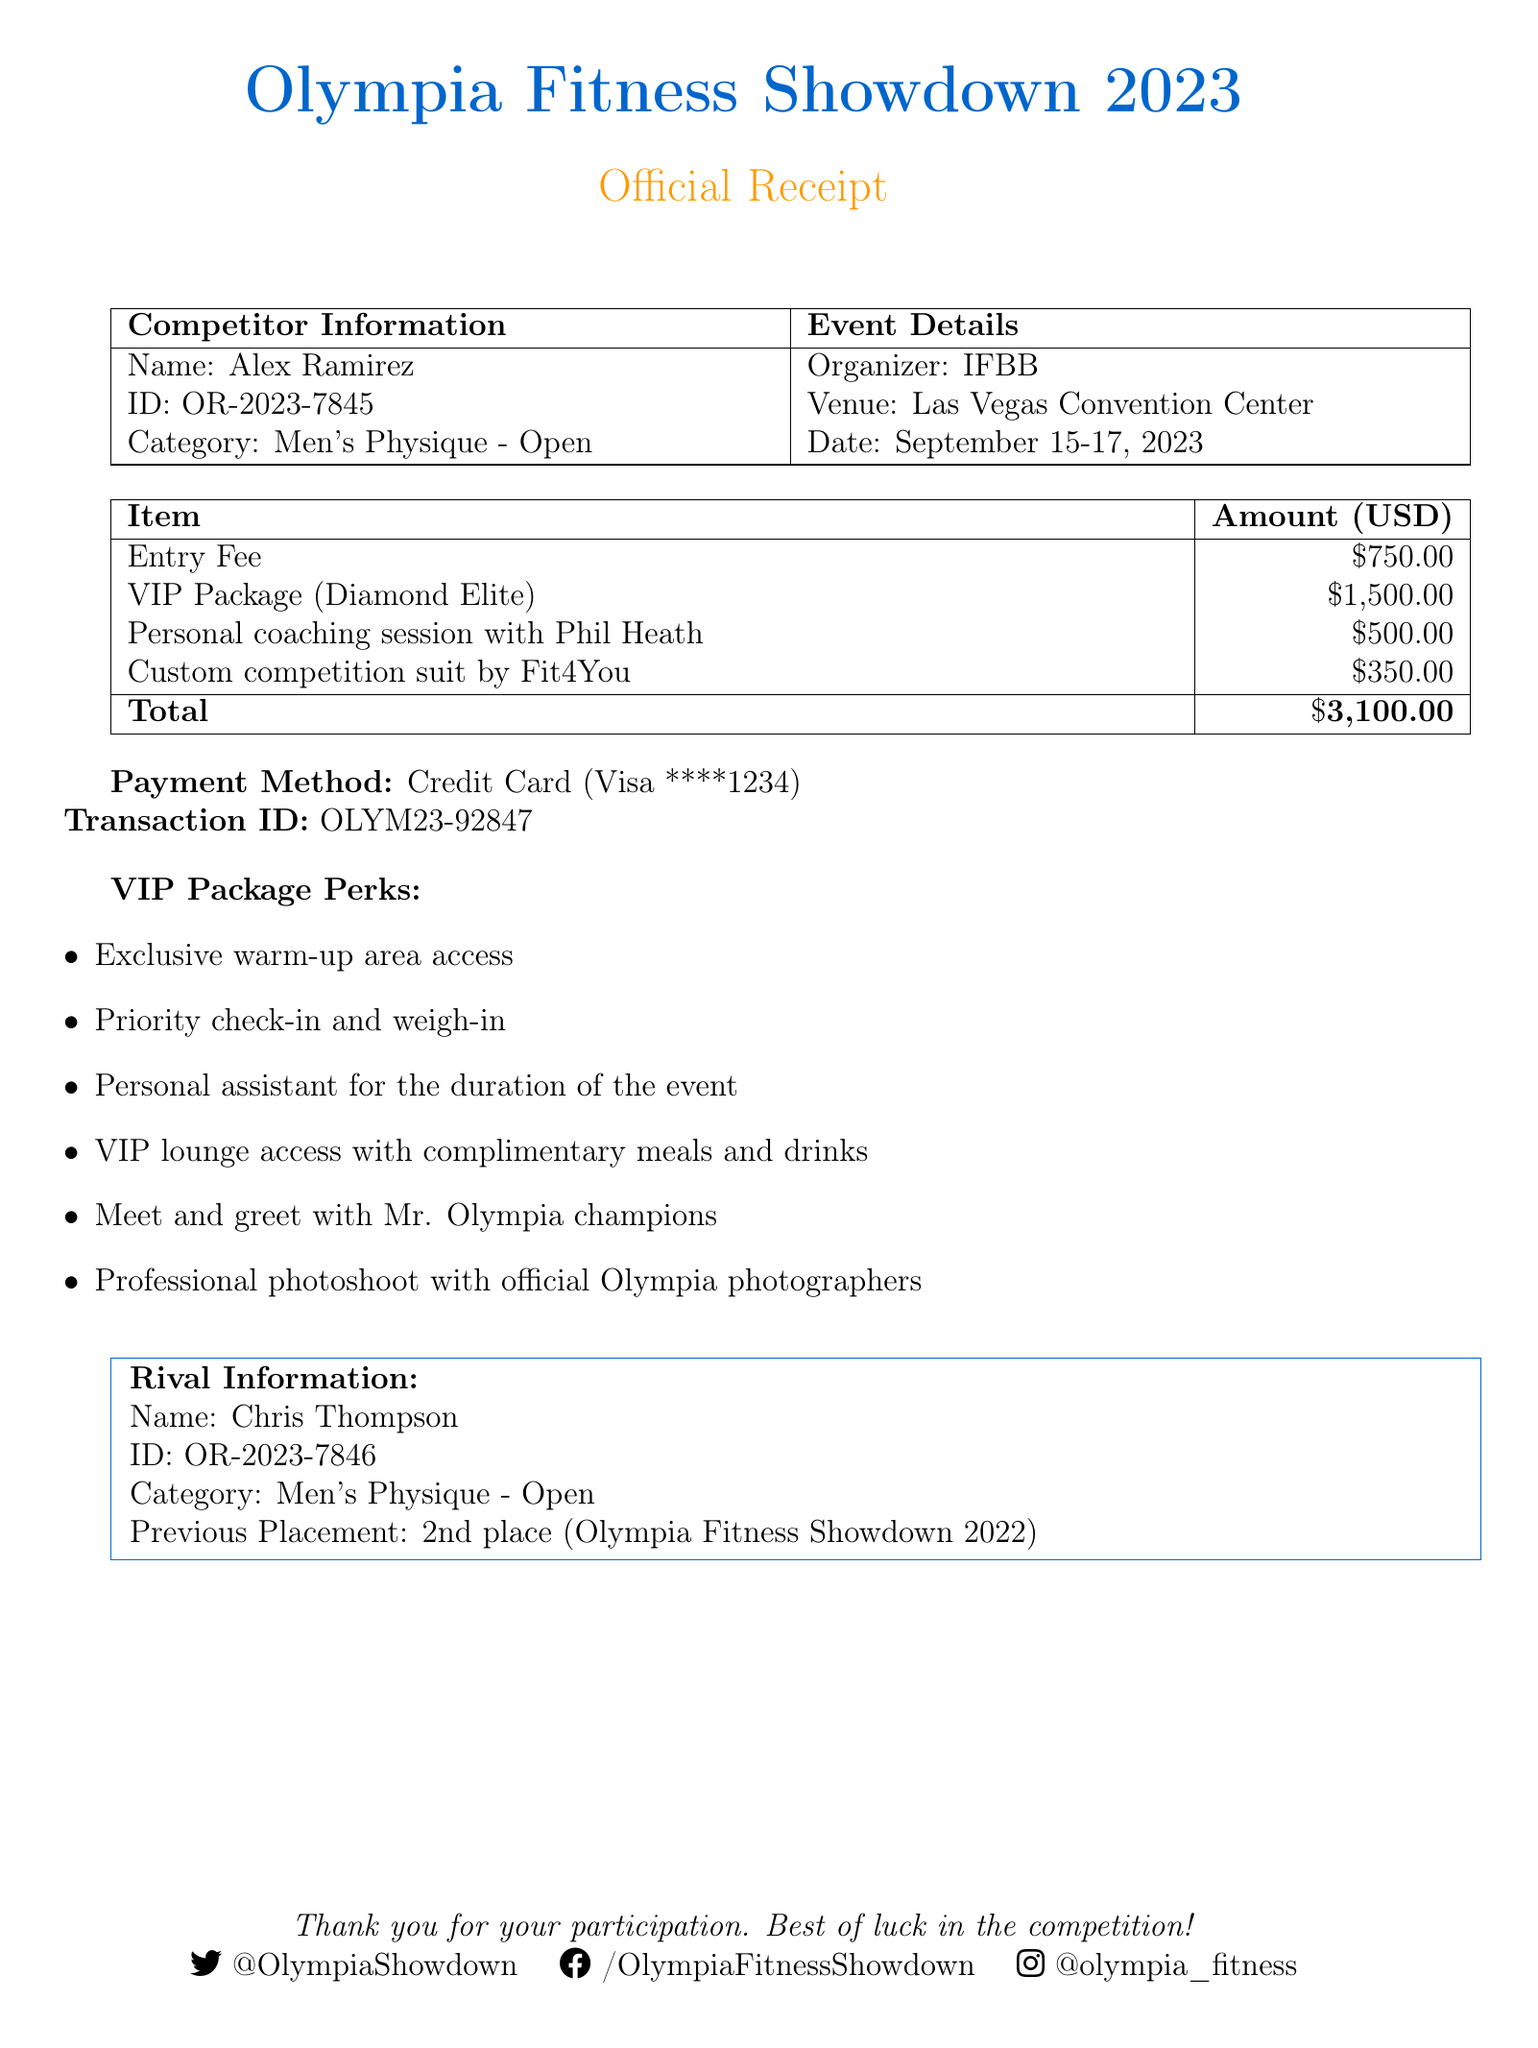What is the competition name? The competition name is stated at the top of the document as part of the title.
Answer: Olympia Fitness Showdown 2023 What is the entry fee amount? The entry fee amount is specified in the financial table section of the document.
Answer: $750.00 Who issued the receipt? The name of the person who issued the receipt is shown in the header section.
Answer: Sarah Johnson What is the transaction ID? The transaction ID is noted under the payment details.
Answer: OLYM23-92847 What is the total amount charged? The total amount charged is the sum of the entry fee, VIP package, and additional services listed.
Answer: $3,100.00 How many VIP perks are listed? The VIP perks section lists all the special benefits included in the VIP package.
Answer: Six What category is the competitor participating in? The category is specified in the competitor information section of the document.
Answer: Men's Physique - Open What additional service has the highest price? The additional services listed contain prices where one is the highest among others.
Answer: Personal coaching session with Phil Heath What is the competitor's rival's previous placement? The document contains a section dedicated to rival information with past achievement details.
Answer: 2nd place (Olympia Fitness Showdown 2022) 